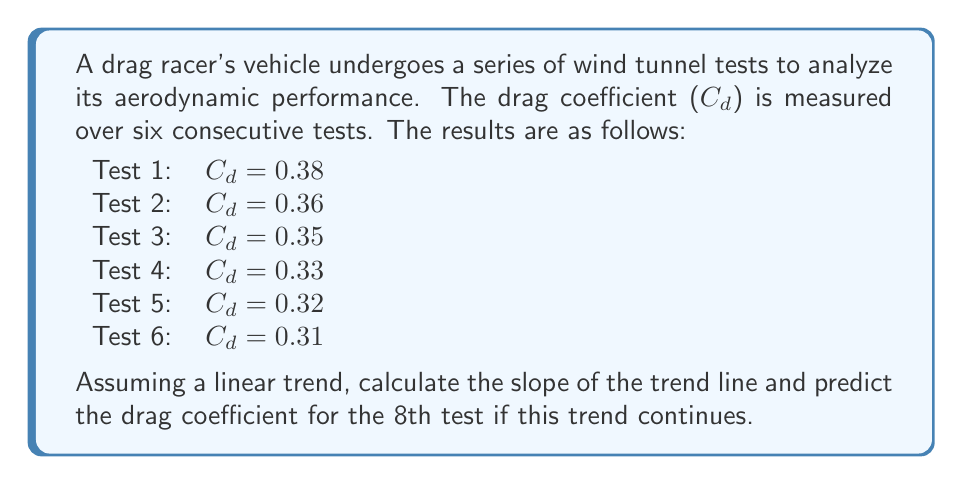Show me your answer to this math problem. To analyze the trend of drag coefficients and make a prediction, we'll use linear regression.

1. First, let's set up our data:
   $x$ (test number): 1, 2, 3, 4, 5, 6
   $y$ ($C_d$ values): 0.38, 0.36, 0.35, 0.33, 0.32, 0.31

2. We'll use the formula for the slope of the linear regression line:

   $$m = \frac{n\sum xy - \sum x \sum y}{n\sum x^2 - (\sum x)^2}$$

   Where $n$ is the number of data points, $x$ is the test number, and $y$ is the $C_d$ value.

3. Calculate the required sums:
   $n = 6$
   $\sum x = 1 + 2 + 3 + 4 + 5 + 6 = 21$
   $\sum y = 0.38 + 0.36 + 0.35 + 0.33 + 0.32 + 0.31 = 2.05$
   $\sum xy = (1)(0.38) + (2)(0.36) + (3)(0.35) + (4)(0.33) + (5)(0.32) + (6)(0.31) = 6.89$
   $\sum x^2 = 1^2 + 2^2 + 3^2 + 4^2 + 5^2 + 6^2 = 91$

4. Plug these values into the slope formula:

   $$m = \frac{6(6.89) - (21)(2.05)}{6(91) - (21)^2} = \frac{41.34 - 43.05}{546 - 441} = \frac{-1.71}{105} = -0.01629$$

5. The slope is approximately -0.0163, indicating that the drag coefficient decreases by about 0.0163 per test.

6. To predict the 8th test, we can use the point-slope form of a line:
   $y - y_1 = m(x - x_1)$

   Let's use the first data point $(1, 0.38)$ as $(x_1, y_1)$:
   $y - 0.38 = -0.01629(x - 1)$

7. Solve for $y$ when $x = 8$:
   $y - 0.38 = -0.01629(8 - 1)$
   $y - 0.38 = -0.11403$
   $y = 0.38 - 0.11403 = 0.26597$

Therefore, the predicted drag coefficient for the 8th test is approximately 0.266.
Answer: The slope of the trend line is approximately -0.0163, and the predicted drag coefficient for the 8th test is approximately 0.266. 